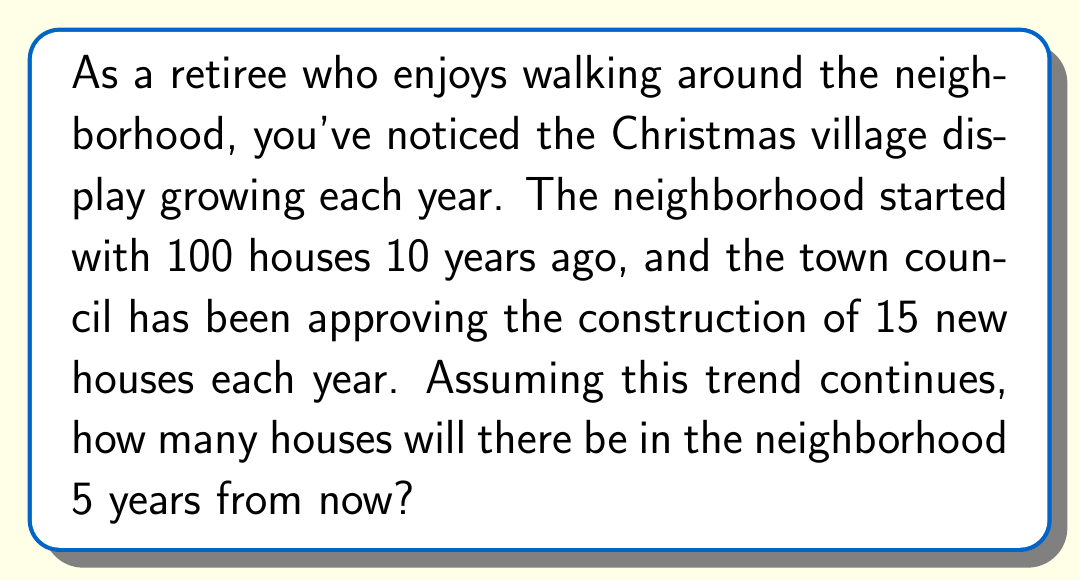Solve this math problem. Let's approach this problem using an arithmetic sequence:

1) First, identify the components of the arithmetic sequence:
   $a_1 = 100$ (initial number of houses)
   $d = 15$ (common difference, houses added each year)

2) We need to find the 15th term of the sequence (10 years ago + 5 years from now)

3) The formula for the nth term of an arithmetic sequence is:
   $a_n = a_1 + (n - 1)d$

4) Substituting our values:
   $a_{15} = 100 + (15 - 1)15$

5) Simplify:
   $a_{15} = 100 + (14)(15)$
   $a_{15} = 100 + 210$
   $a_{15} = 310$

Therefore, in 5 years, there will be 310 houses in the neighborhood.
Answer: 310 houses 